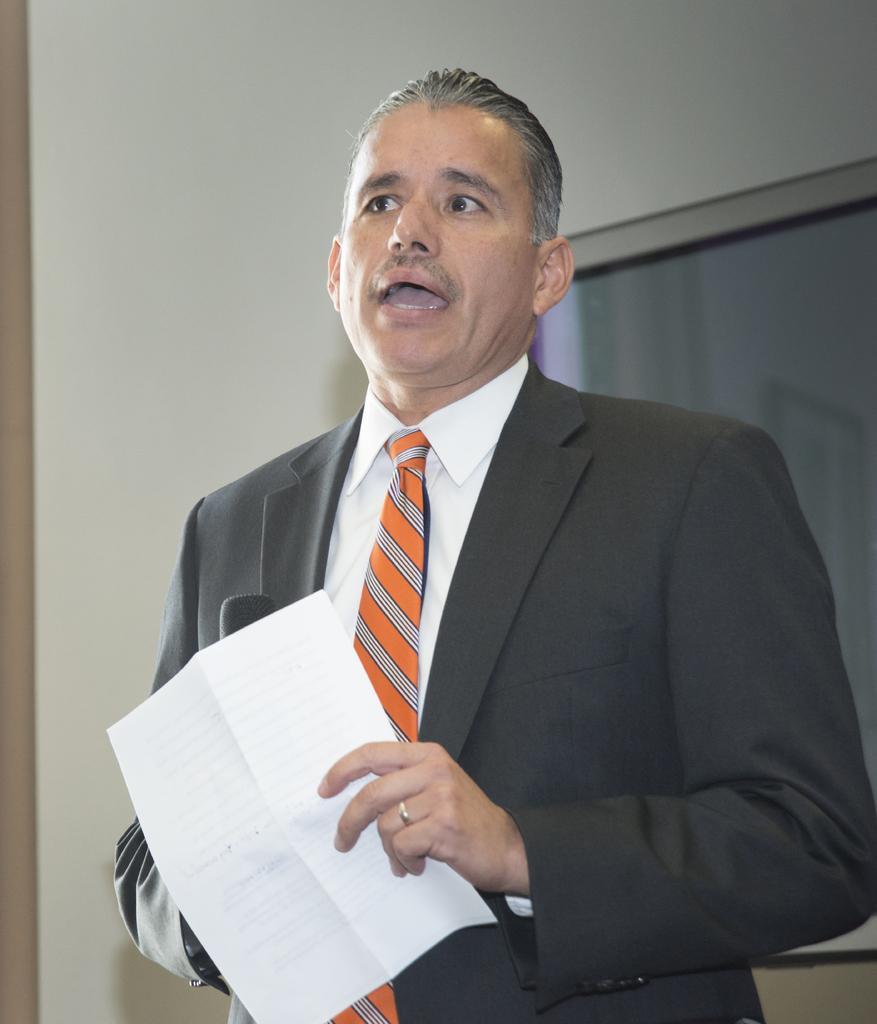Describe this image in one or two sentences. In this image we can see a person holding paper in his hands. In the background we can see window and walls. 